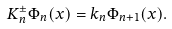<formula> <loc_0><loc_0><loc_500><loc_500>K _ { n } ^ { \pm } \Phi _ { n } ( x ) = k _ { n } \Phi _ { n + 1 } ( x ) .</formula> 